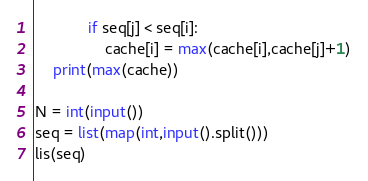Convert code to text. <code><loc_0><loc_0><loc_500><loc_500><_Python_>			if seq[j] < seq[i]:
				cache[i] = max(cache[i],cache[j]+1)
	print(max(cache))
	
N = int(input())
seq = list(map(int,input().split()))
lis(seq)
</code> 